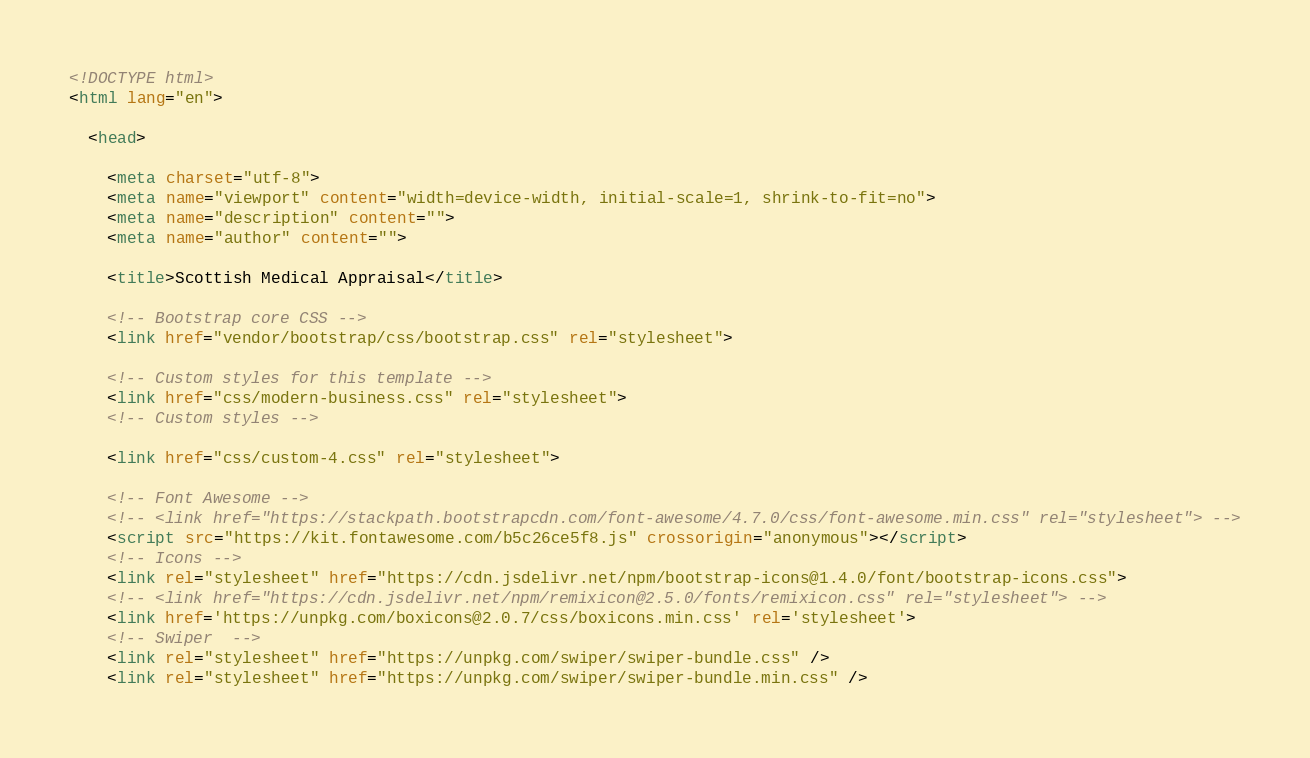Convert code to text. <code><loc_0><loc_0><loc_500><loc_500><_HTML_><!DOCTYPE html>
<html lang="en">

  <head>

    <meta charset="utf-8">
    <meta name="viewport" content="width=device-width, initial-scale=1, shrink-to-fit=no">
    <meta name="description" content="">
    <meta name="author" content="">

    <title>Scottish Medical Appraisal</title>

    <!-- Bootstrap core CSS -->
    <link href="vendor/bootstrap/css/bootstrap.css" rel="stylesheet">

    <!-- Custom styles for this template -->
    <link href="css/modern-business.css" rel="stylesheet">
    <!-- Custom styles -->
    
    <link href="css/custom-4.css" rel="stylesheet">
    
    <!-- Font Awesome -->
    <!-- <link href="https://stackpath.bootstrapcdn.com/font-awesome/4.7.0/css/font-awesome.min.css" rel="stylesheet"> -->
    <script src="https://kit.fontawesome.com/b5c26ce5f8.js" crossorigin="anonymous"></script>
    <!-- Icons -->
    <link rel="stylesheet" href="https://cdn.jsdelivr.net/npm/bootstrap-icons@1.4.0/font/bootstrap-icons.css">
    <!-- <link href="https://cdn.jsdelivr.net/npm/remixicon@2.5.0/fonts/remixicon.css" rel="stylesheet"> -->
    <link href='https://unpkg.com/boxicons@2.0.7/css/boxicons.min.css' rel='stylesheet'>
    <!-- Swiper  -->
    <link rel="stylesheet" href="https://unpkg.com/swiper/swiper-bundle.css" />
    <link rel="stylesheet" href="https://unpkg.com/swiper/swiper-bundle.min.css" />

</code> 